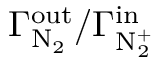Convert formula to latex. <formula><loc_0><loc_0><loc_500><loc_500>\Gamma _ { N _ { 2 } } ^ { o u t } / \Gamma _ { N _ { 2 } ^ { + } } ^ { i n }</formula> 